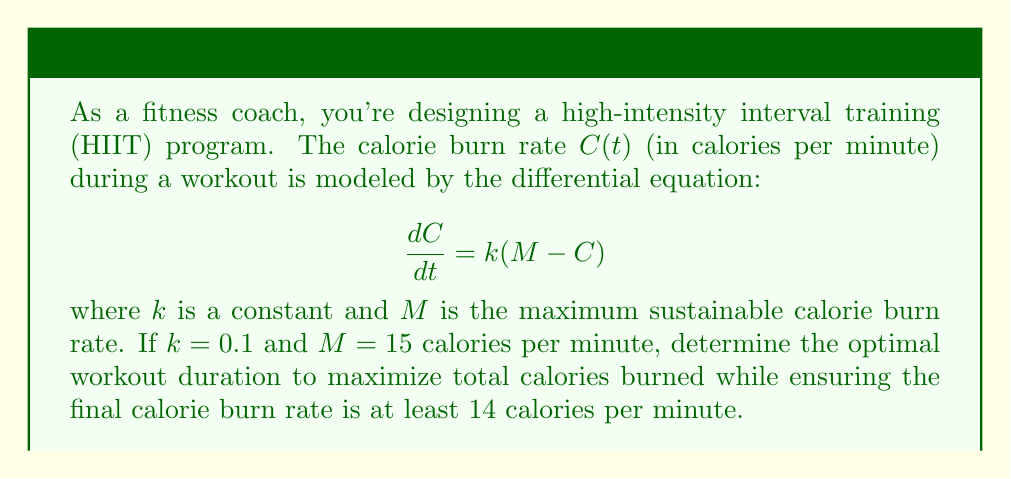Could you help me with this problem? To solve this problem, we'll follow these steps:

1) First, we need to solve the differential equation:
   $$\frac{dC}{dt} = k(M - C)$$
   
   This is a separable equation. Rearranging:
   $$\frac{dC}{M - C} = k dt$$

2) Integrating both sides:
   $$-\ln|M - C| = kt + A$$
   where $A$ is the constant of integration.

3) Solving for $C$:
   $$C = M - Be^{-kt}$$
   where $B = e^A$.

4) To find $B$, we use the initial condition. Assume $C(0) = 0$ (starting from rest):
   $$0 = M - B$$
   $$B = M = 15$$

5) So our solution is:
   $$C(t) = 15(1 - e^{-0.1t})$$

6) The total calories burned is the integral of $C(t)$ from 0 to $t$:
   $$\text{Total Calories} = \int_0^t C(τ) dτ = 15t + 150(e^{-0.1t} - 1)$$

7) We want $C(t) ≥ 14$ at the end of the workout. Solving:
   $$14 ≤ 15(1 - e^{-0.1t})$$
   $$e^{-0.1t} ≤ \frac{1}{15}$$
   $$t ≥ -10\ln(\frac{1}{15}) ≈ 27.03 \text{ minutes}$$

8) The total calories burned increases with time, so the optimal duration is the minimum time that satisfies the final burn rate condition, which is approximately 27.03 minutes.

9) The total calories burned in this time is:
   $$15(27.03) + 150(e^{-0.1(27.03)} - 1) ≈ 392.7 \text{ calories}$$
Answer: 27.03 minutes, burning approximately 392.7 calories 